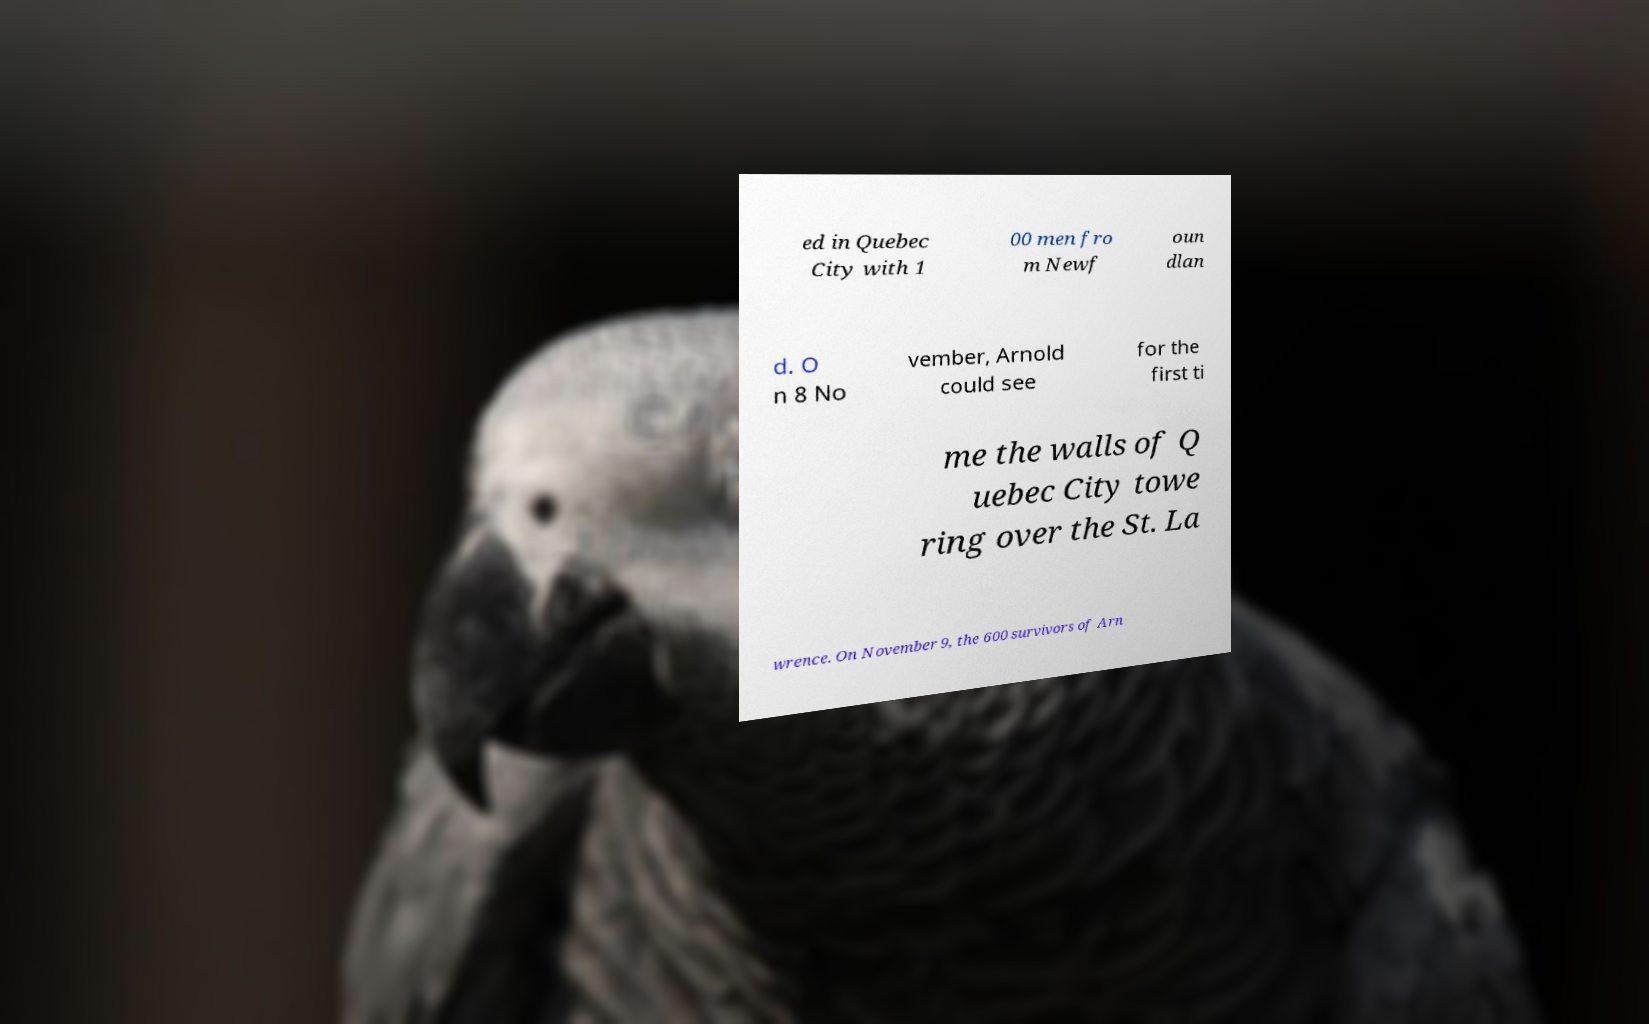I need the written content from this picture converted into text. Can you do that? ed in Quebec City with 1 00 men fro m Newf oun dlan d. O n 8 No vember, Arnold could see for the first ti me the walls of Q uebec City towe ring over the St. La wrence. On November 9, the 600 survivors of Arn 